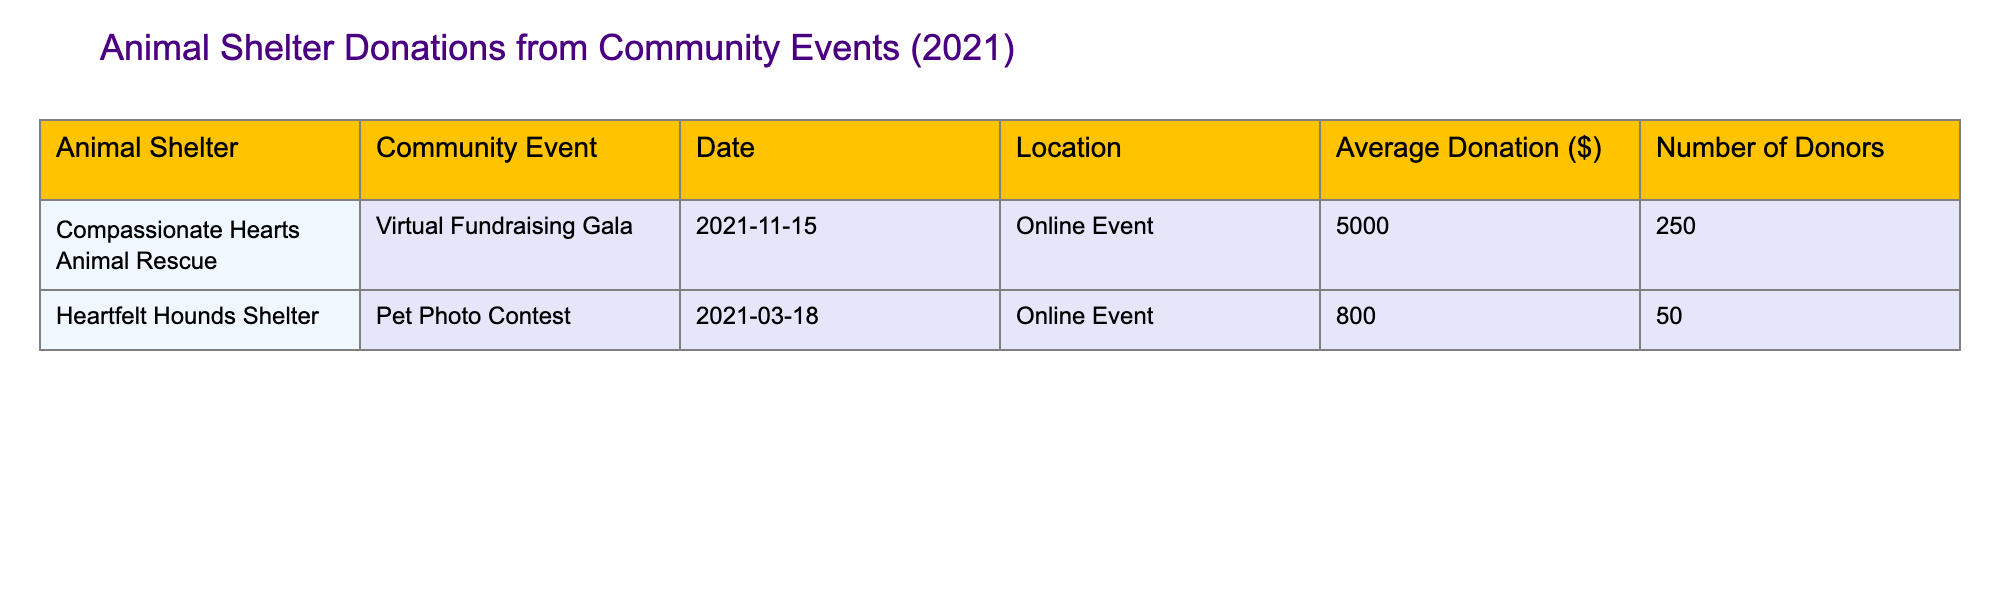What is the average donation received from the "Virtual Fundraising Gala"? The table lists the average donation for the "Virtual Fundraising Gala" as $5000.
Answer: 5000 How many donors participated in the "Pet Photo Contest"? According to the table, the "Pet Photo Contest" had 50 donors participating.
Answer: 50 What total amount was donated by all donors in the "Virtual Fundraising Gala"? To find the total donation, multiply the average donation of $5000 by the number of donors (250). This gives $5000 * 250 = $1,250,000.
Answer: 1,250,000 Which community event received the highest average donation? The table shows that the "Virtual Fundraising Gala" received $5000, whereas the "Pet Photo Contest" received $800. Therefore, the "Virtual Fundraising Gala" received the highest average donation.
Answer: Virtual Fundraising Gala Are there any events where the average donation was more than $1000? The "Virtual Fundraising Gala" has an average donation of $5000, which is more than $1000, whereas the "Pet Photo Contest" was $800. So yes, there is one event that had an average donation above $1000.
Answer: Yes What is the combined average donation of both events? To find the combined average, add the two average donations: $5000 + $800 = $5800. Then divide by the number of events (2). So, $5800 / 2 = $2900.
Answer: 2900 What is the difference in average donations between the two events? To find the difference, subtract the average donation of the "Pet Photo Contest" ($800) from the "Virtual Fundraising Gala" ($5000). This results in $5000 - $800 = $4200.
Answer: 4200 How many total donors participated in both events combined? To find this, add the number of donors from both events: 250 (from "Virtual Fundraising Gala") + 50 (from "Pet Photo Contest") = 300 donors in total.
Answer: 300 Was there any online event that had an average donation exceeding $3000? The only online event listed is the "Virtual Fundraising Gala," which had an average donation of $5000, exceeding $3000. Therefore, the answer is yes.
Answer: Yes 